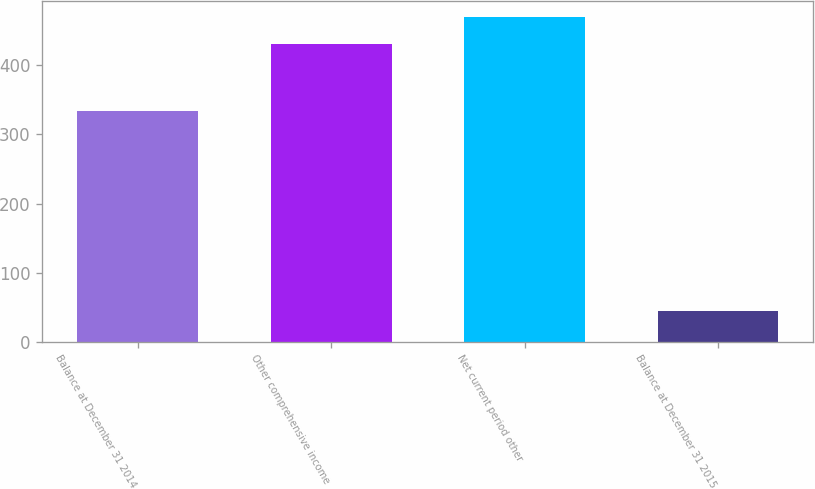Convert chart. <chart><loc_0><loc_0><loc_500><loc_500><bar_chart><fcel>Balance at December 31 2014<fcel>Other comprehensive income<fcel>Net current period other<fcel>Balance at December 31 2015<nl><fcel>334<fcel>431<fcel>469.6<fcel>45<nl></chart> 